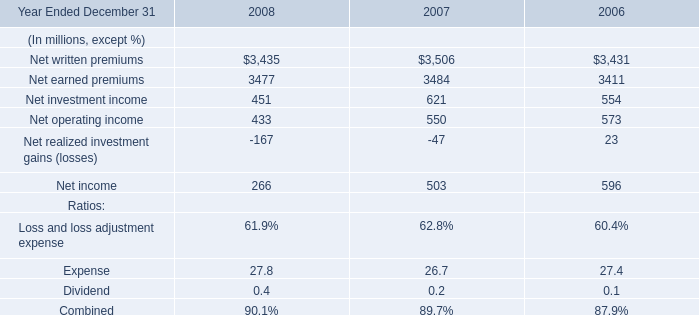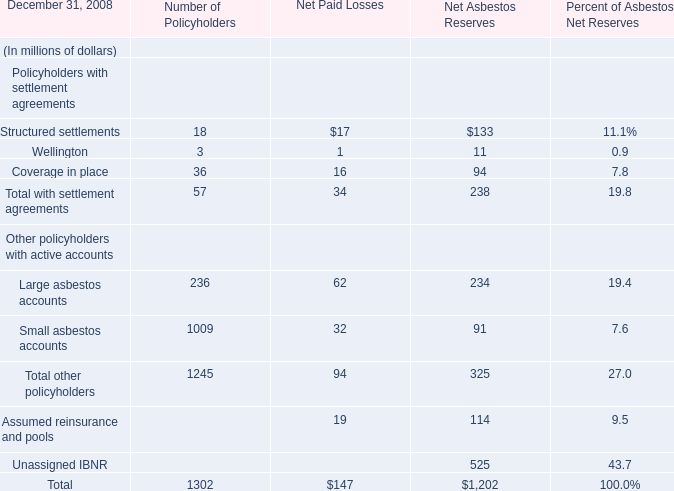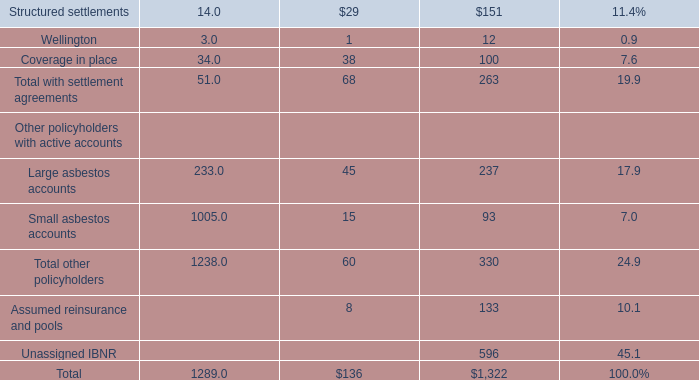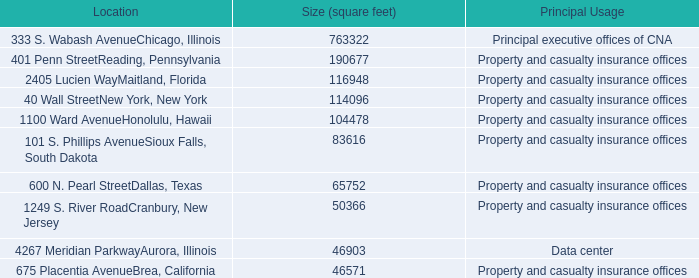What is the ratio of all elements that are smaller than 100 to the sum of elements, for Number of Policyholders? 
Computations: (((18 + 3) + 36) / 1302)
Answer: 0.04378. 